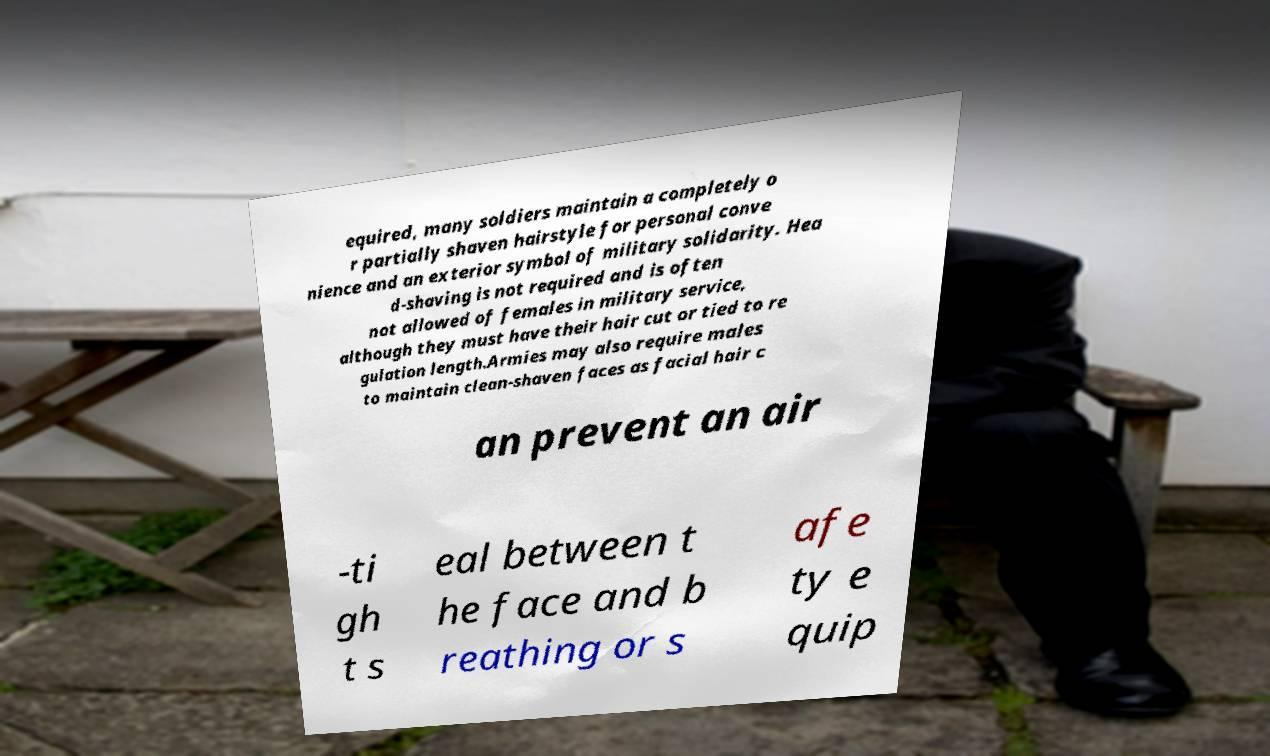I need the written content from this picture converted into text. Can you do that? equired, many soldiers maintain a completely o r partially shaven hairstyle for personal conve nience and an exterior symbol of military solidarity. Hea d-shaving is not required and is often not allowed of females in military service, although they must have their hair cut or tied to re gulation length.Armies may also require males to maintain clean-shaven faces as facial hair c an prevent an air -ti gh t s eal between t he face and b reathing or s afe ty e quip 